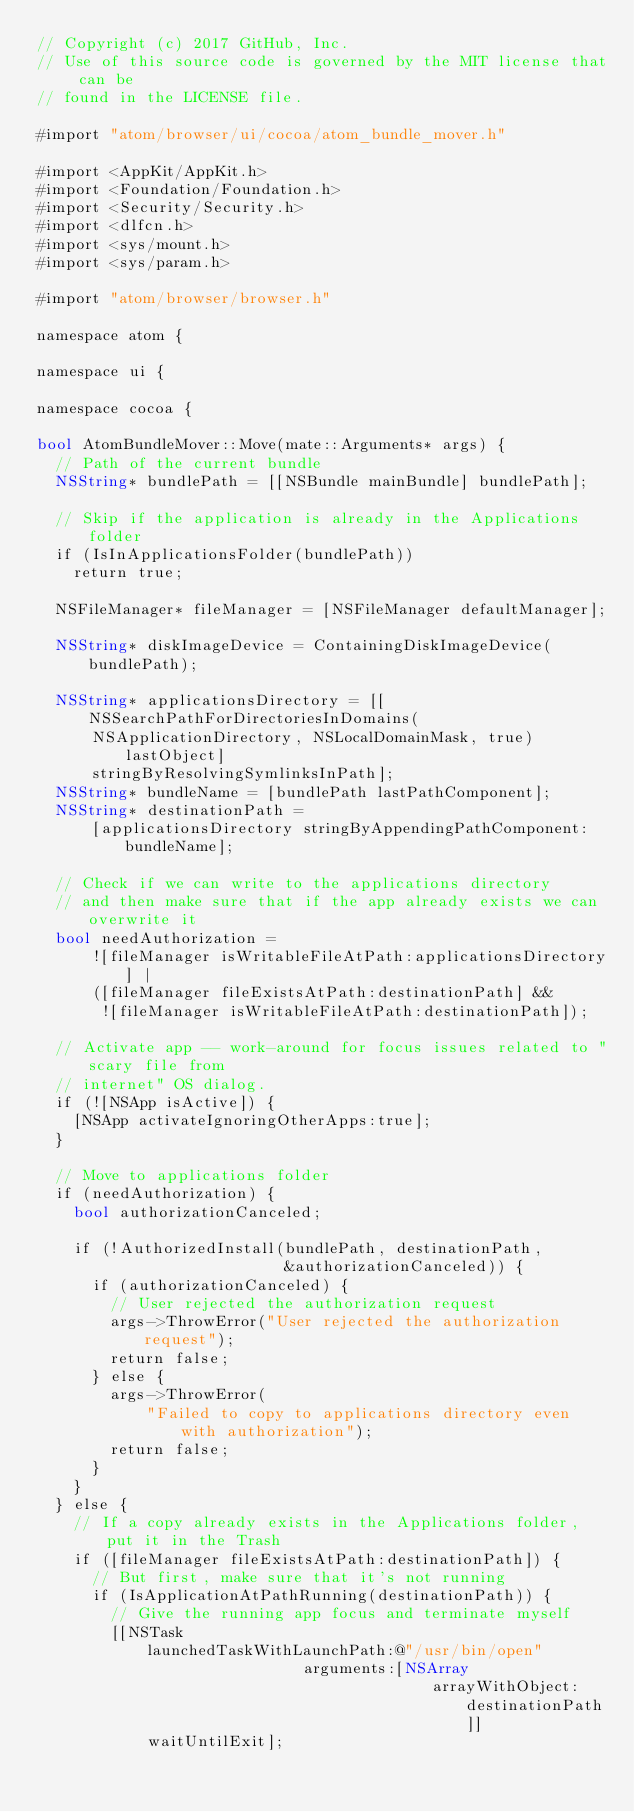<code> <loc_0><loc_0><loc_500><loc_500><_ObjectiveC_>// Copyright (c) 2017 GitHub, Inc.
// Use of this source code is governed by the MIT license that can be
// found in the LICENSE file.

#import "atom/browser/ui/cocoa/atom_bundle_mover.h"

#import <AppKit/AppKit.h>
#import <Foundation/Foundation.h>
#import <Security/Security.h>
#import <dlfcn.h>
#import <sys/mount.h>
#import <sys/param.h>

#import "atom/browser/browser.h"

namespace atom {

namespace ui {

namespace cocoa {

bool AtomBundleMover::Move(mate::Arguments* args) {
  // Path of the current bundle
  NSString* bundlePath = [[NSBundle mainBundle] bundlePath];

  // Skip if the application is already in the Applications folder
  if (IsInApplicationsFolder(bundlePath))
    return true;

  NSFileManager* fileManager = [NSFileManager defaultManager];

  NSString* diskImageDevice = ContainingDiskImageDevice(bundlePath);

  NSString* applicationsDirectory = [[NSSearchPathForDirectoriesInDomains(
      NSApplicationDirectory, NSLocalDomainMask, true) lastObject]
      stringByResolvingSymlinksInPath];
  NSString* bundleName = [bundlePath lastPathComponent];
  NSString* destinationPath =
      [applicationsDirectory stringByAppendingPathComponent:bundleName];

  // Check if we can write to the applications directory
  // and then make sure that if the app already exists we can overwrite it
  bool needAuthorization =
      ![fileManager isWritableFileAtPath:applicationsDirectory] |
      ([fileManager fileExistsAtPath:destinationPath] &&
       ![fileManager isWritableFileAtPath:destinationPath]);

  // Activate app -- work-around for focus issues related to "scary file from
  // internet" OS dialog.
  if (![NSApp isActive]) {
    [NSApp activateIgnoringOtherApps:true];
  }

  // Move to applications folder
  if (needAuthorization) {
    bool authorizationCanceled;

    if (!AuthorizedInstall(bundlePath, destinationPath,
                           &authorizationCanceled)) {
      if (authorizationCanceled) {
        // User rejected the authorization request
        args->ThrowError("User rejected the authorization request");
        return false;
      } else {
        args->ThrowError(
            "Failed to copy to applications directory even with authorization");
        return false;
      }
    }
  } else {
    // If a copy already exists in the Applications folder, put it in the Trash
    if ([fileManager fileExistsAtPath:destinationPath]) {
      // But first, make sure that it's not running
      if (IsApplicationAtPathRunning(destinationPath)) {
        // Give the running app focus and terminate myself
        [[NSTask
            launchedTaskWithLaunchPath:@"/usr/bin/open"
                             arguments:[NSArray
                                           arrayWithObject:destinationPath]]
            waitUntilExit];</code> 